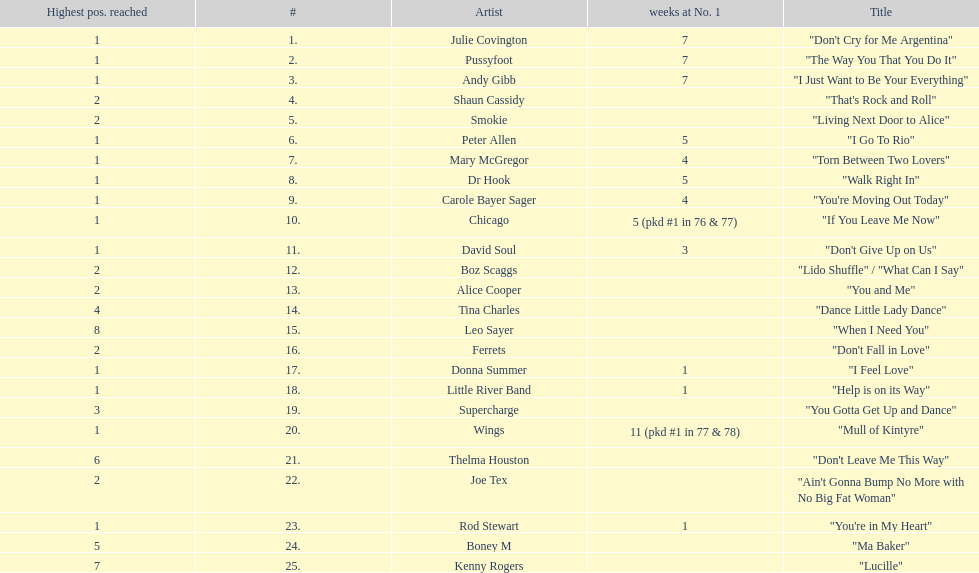Which three artists had a single at number 1 for at least 7 weeks on the australian singles charts in 1977? Julie Covington, Pussyfoot, Andy Gibb. 